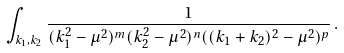Convert formula to latex. <formula><loc_0><loc_0><loc_500><loc_500>\int _ { k _ { 1 } , k _ { 2 } } \frac { 1 } { ( k _ { 1 } ^ { 2 } - \mu ^ { 2 } ) ^ { m } ( k _ { 2 } ^ { 2 } - \mu ^ { 2 } ) ^ { n } ( ( k _ { 1 } + k _ { 2 } ) ^ { 2 } - \mu ^ { 2 } ) ^ { p } } \, .</formula> 